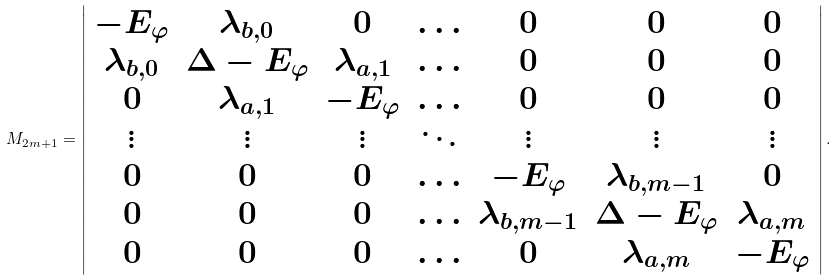Convert formula to latex. <formula><loc_0><loc_0><loc_500><loc_500>M _ { 2 m + 1 } = \left | \begin{array} { c c c c c c c } - E _ { \varphi } & \lambda _ { b , 0 } & 0 & \hdots & 0 & 0 & 0 \\ \lambda _ { b , 0 } & \Delta - E _ { \varphi } & \lambda _ { a , 1 } & \hdots & 0 & 0 & 0 \\ 0 & \lambda _ { a , 1 } & - E _ { \varphi } & \hdots & 0 & 0 & 0 \\ \vdots & \vdots & \vdots & \ddots & \vdots & \vdots & \vdots \\ 0 & 0 & 0 & \hdots & - E _ { \varphi } & \lambda _ { b , m - 1 } & 0 \\ 0 & 0 & 0 & \hdots & \lambda _ { b , m - 1 } & \Delta - E _ { \varphi } & \lambda _ { a , m } \\ 0 & 0 & 0 & \hdots & 0 & \lambda _ { a , m } & - E _ { \varphi } \end{array} \right | .</formula> 